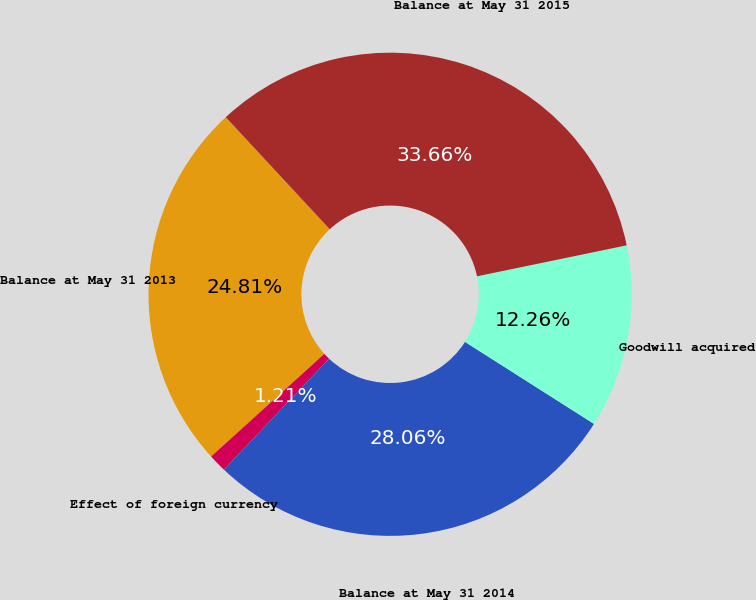Convert chart to OTSL. <chart><loc_0><loc_0><loc_500><loc_500><pie_chart><fcel>Balance at May 31 2013<fcel>Effect of foreign currency<fcel>Balance at May 31 2014<fcel>Goodwill acquired<fcel>Balance at May 31 2015<nl><fcel>24.81%<fcel>1.21%<fcel>28.06%<fcel>12.26%<fcel>33.66%<nl></chart> 